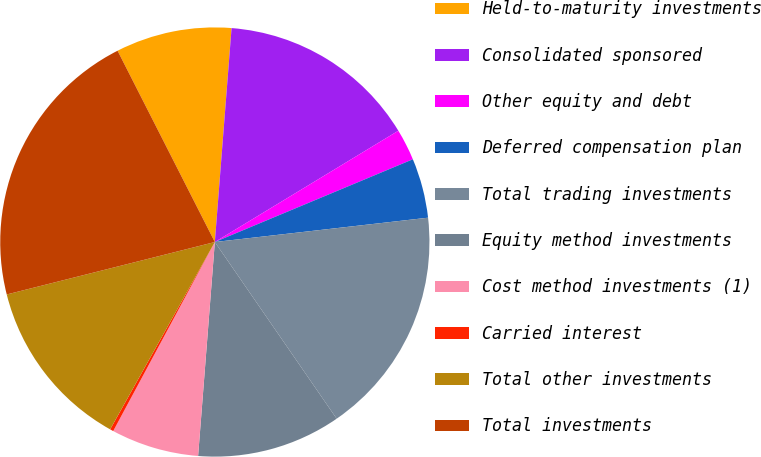Convert chart. <chart><loc_0><loc_0><loc_500><loc_500><pie_chart><fcel>Held-to-maturity investments<fcel>Consolidated sponsored<fcel>Other equity and debt<fcel>Deferred compensation plan<fcel>Total trading investments<fcel>Equity method investments<fcel>Cost method investments (1)<fcel>Carried interest<fcel>Total other investments<fcel>Total investments<nl><fcel>8.73%<fcel>15.08%<fcel>2.38%<fcel>4.49%<fcel>17.2%<fcel>10.85%<fcel>6.61%<fcel>0.26%<fcel>12.96%<fcel>21.44%<nl></chart> 